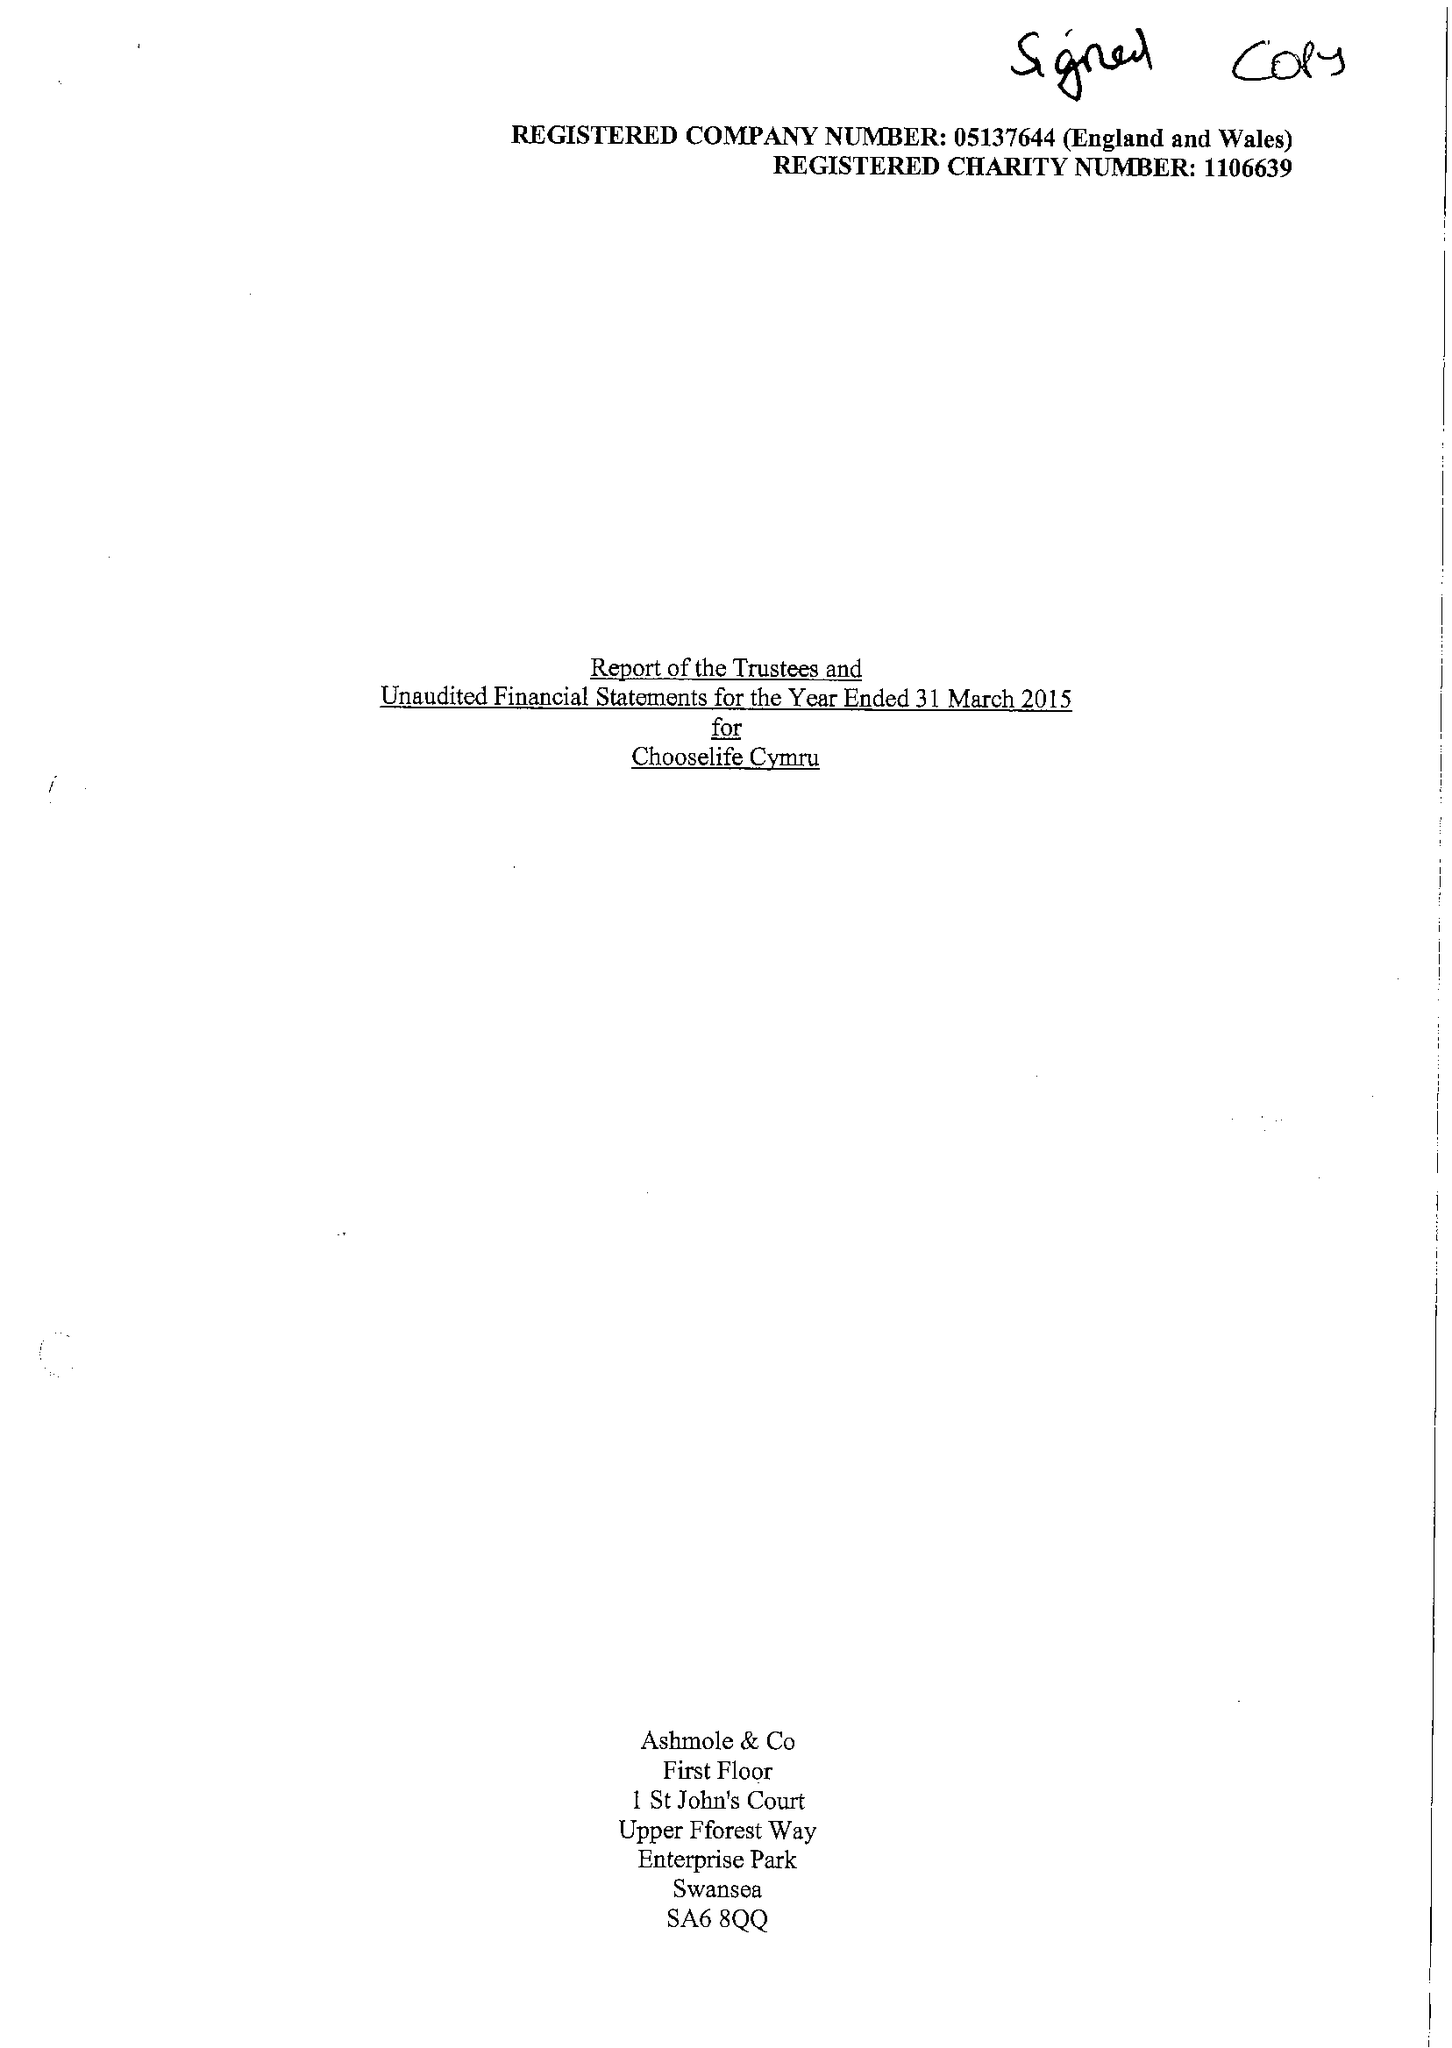What is the value for the income_annually_in_british_pounds?
Answer the question using a single word or phrase. 358945.00 